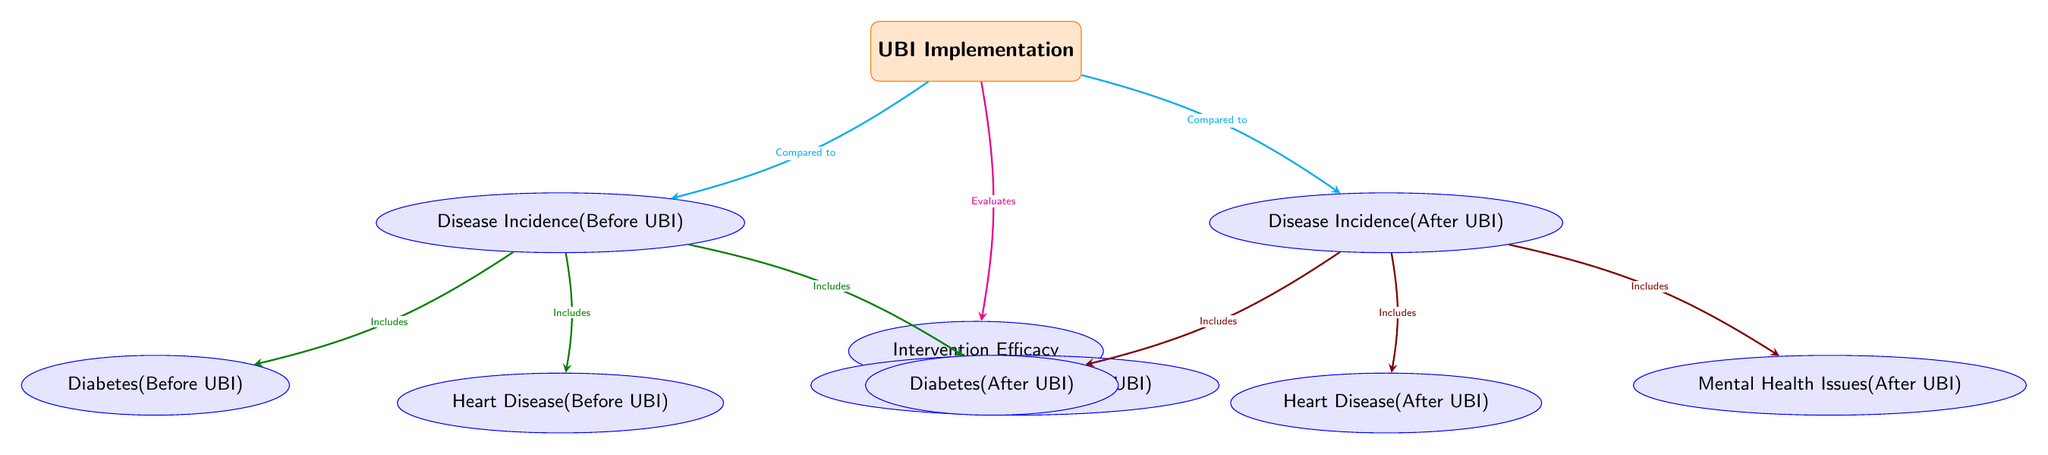What is the primary focus of the diagram? The diagram primarily focuses on the comparison of disease incidence rates before and after the implementation of UBI. This is shown by the nodes marked "Disease Incidence (Before UBI)" and "Disease Incidence (After UBI)", connected to the central "UBI Implementation" event.
Answer: UBI Implementation How many disease categories are represented in the diagram? There are three distinct disease categories illustrated in the diagram: Diabetes, Heart Disease, and Mental Health Issues. These categories are shown as sub-nodes branching from the before and after nodes.
Answer: 3 Which diseases are included in the "Before UBI" category? The diseases included in the "Before UBI" category are Diabetes, Heart Disease, and Mental Health Issues as indicated in the nodes connected to "Disease Incidence (Before UBI)".
Answer: Diabetes, Heart Disease, Mental Health Issues Which node evaluates intervention efficacy? The node labeled "Intervention Efficacy" evaluates the effects of interventions performed, which is connected to the UBI implementation event. This reflects the assessment of how UBI impacts disease incidence.
Answer: Intervention Efficacy What color represents the connections to the "After UBI" category? The connections to the "After UBI" category are represented in red with a specific hue, as observed from the edges leading from "Disease Incidence (After UBI)" to its sub-nodes for the respective diseases.
Answer: Red What do the arrows indicate in this diagram? The arrows in this diagram indicate the relationships and flow of information between different nodes, showing how UBI relates to disease incidence both before and after its implementation, as well as the evaluations of intervention efficacy.
Answer: Relationships How is the "UBI Implementation" node related to the "Disease Incidence (Before UBI)" node? The "UBI Implementation" node is related to the "Disease Incidence (Before UBI)" node through a cyan-colored arrow, indicating a comparative relationship before the implementation of UBI.
Answer: Compared to What type of diagram is this? This is a Biomedical Diagram, specifically illustrating the relationships between disease incidence and intervention efficacy related to UBI implementation.
Answer: Biomedical Diagram What does the arrow color cyan represent? The cyan arrows represent the comparative aspect of the disease incidences before and after UBI implementation, indicating how the UBI event relates to these two categories of data.
Answer: Compared to 